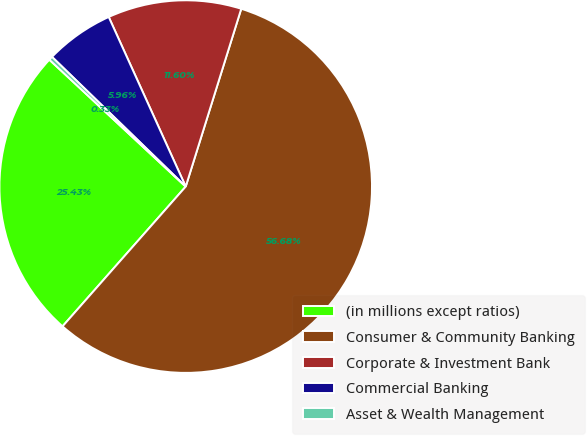Convert chart to OTSL. <chart><loc_0><loc_0><loc_500><loc_500><pie_chart><fcel>(in millions except ratios)<fcel>Consumer & Community Banking<fcel>Corporate & Investment Bank<fcel>Commercial Banking<fcel>Asset & Wealth Management<nl><fcel>25.43%<fcel>56.68%<fcel>11.6%<fcel>5.96%<fcel>0.33%<nl></chart> 